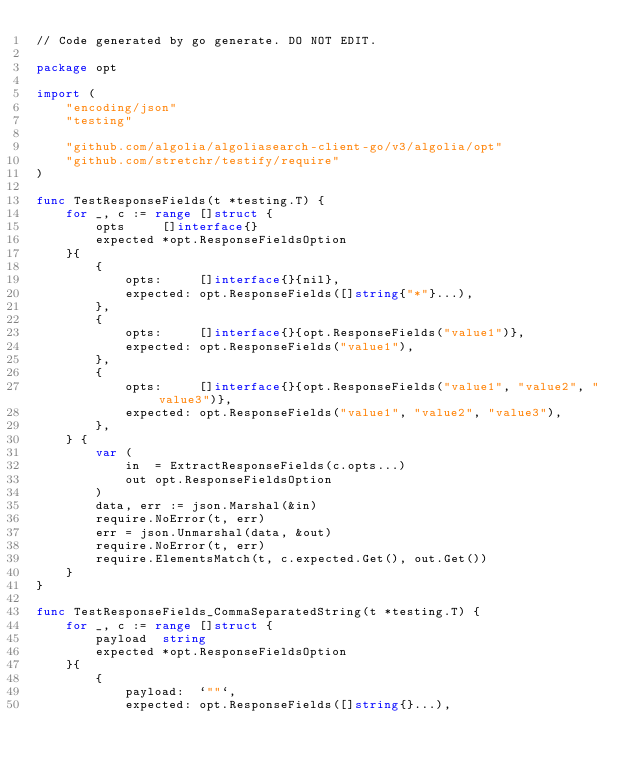<code> <loc_0><loc_0><loc_500><loc_500><_Go_>// Code generated by go generate. DO NOT EDIT.

package opt

import (
	"encoding/json"
	"testing"

	"github.com/algolia/algoliasearch-client-go/v3/algolia/opt"
	"github.com/stretchr/testify/require"
)

func TestResponseFields(t *testing.T) {
	for _, c := range []struct {
		opts     []interface{}
		expected *opt.ResponseFieldsOption
	}{
		{
			opts:     []interface{}{nil},
			expected: opt.ResponseFields([]string{"*"}...),
		},
		{
			opts:     []interface{}{opt.ResponseFields("value1")},
			expected: opt.ResponseFields("value1"),
		},
		{
			opts:     []interface{}{opt.ResponseFields("value1", "value2", "value3")},
			expected: opt.ResponseFields("value1", "value2", "value3"),
		},
	} {
		var (
			in  = ExtractResponseFields(c.opts...)
			out opt.ResponseFieldsOption
		)
		data, err := json.Marshal(&in)
		require.NoError(t, err)
		err = json.Unmarshal(data, &out)
		require.NoError(t, err)
		require.ElementsMatch(t, c.expected.Get(), out.Get())
	}
}

func TestResponseFields_CommaSeparatedString(t *testing.T) {
	for _, c := range []struct {
		payload  string
		expected *opt.ResponseFieldsOption
	}{
		{
			payload:  `""`,
			expected: opt.ResponseFields([]string{}...),</code> 